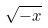<formula> <loc_0><loc_0><loc_500><loc_500>\sqrt { - x }</formula> 